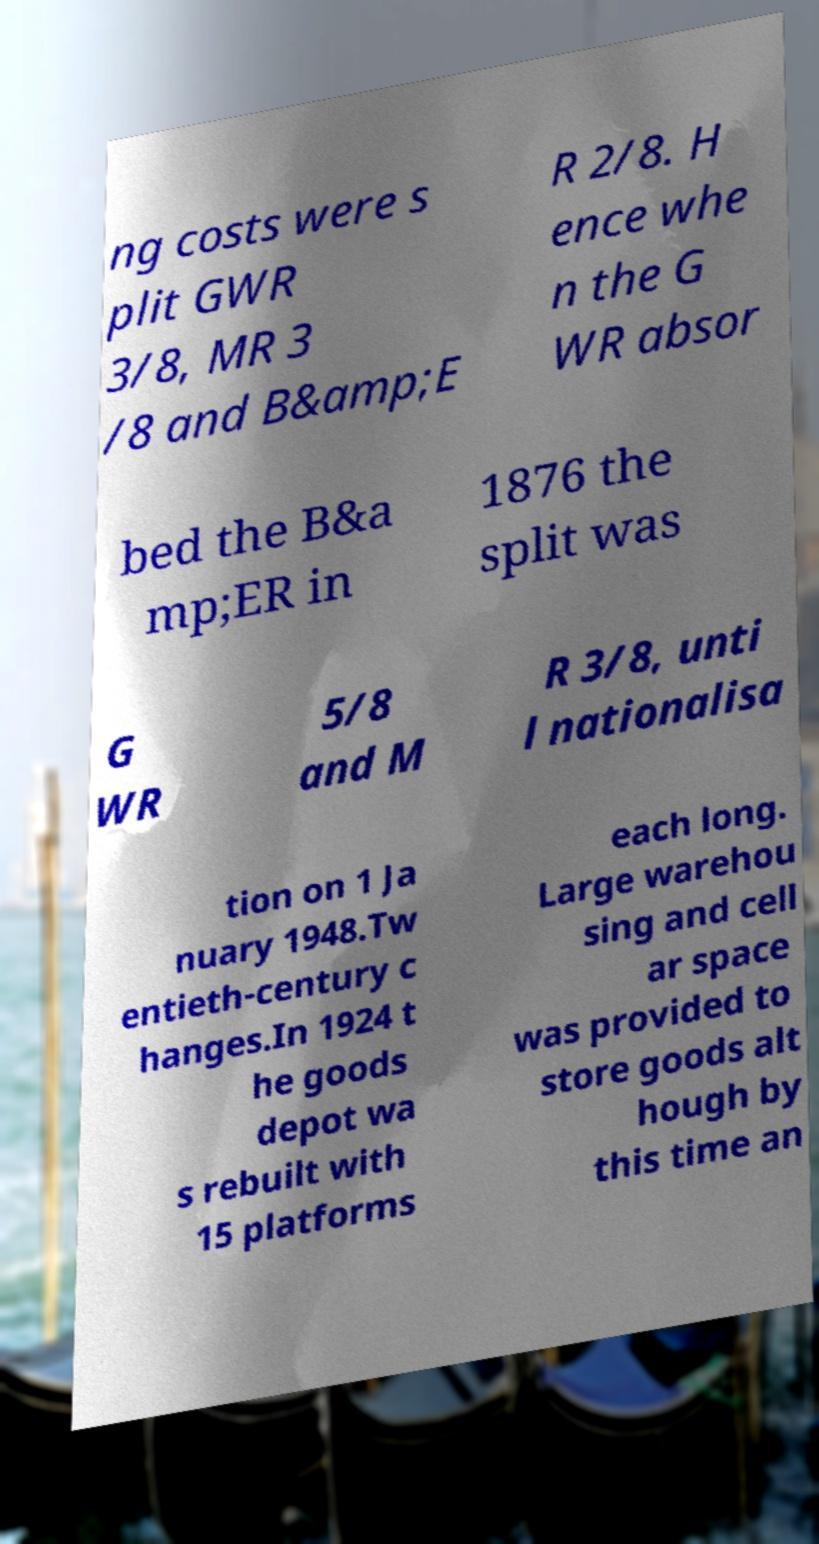Can you read and provide the text displayed in the image?This photo seems to have some interesting text. Can you extract and type it out for me? ng costs were s plit GWR 3/8, MR 3 /8 and B&amp;E R 2/8. H ence whe n the G WR absor bed the B&a mp;ER in 1876 the split was G WR 5/8 and M R 3/8, unti l nationalisa tion on 1 Ja nuary 1948.Tw entieth-century c hanges.In 1924 t he goods depot wa s rebuilt with 15 platforms each long. Large warehou sing and cell ar space was provided to store goods alt hough by this time an 